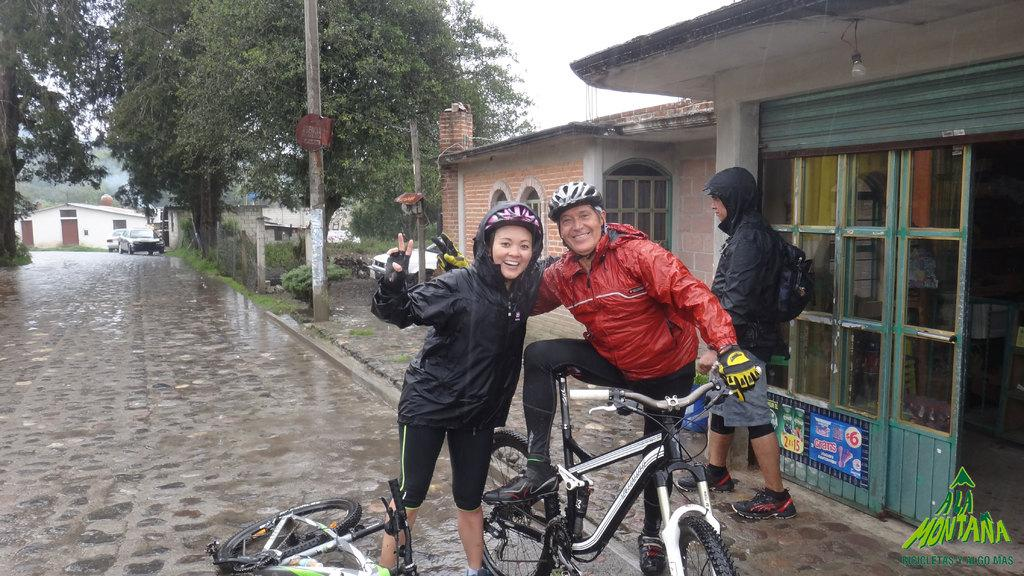How many people are present in the image? There are three people in the image: a man, a woman, and another person standing behind them. What are the man and the woman holding in the image? Both the man and the woman have bicycles with them. What can be seen in the background of the image? There are trees and buildings in the background of the image. What type of honey can be seen dripping from the trees in the image? There is no honey present in the image; it features trees and buildings in the background. Can you tell me how many volleyballs are visible in the image? There are no volleyballs present in the image. 